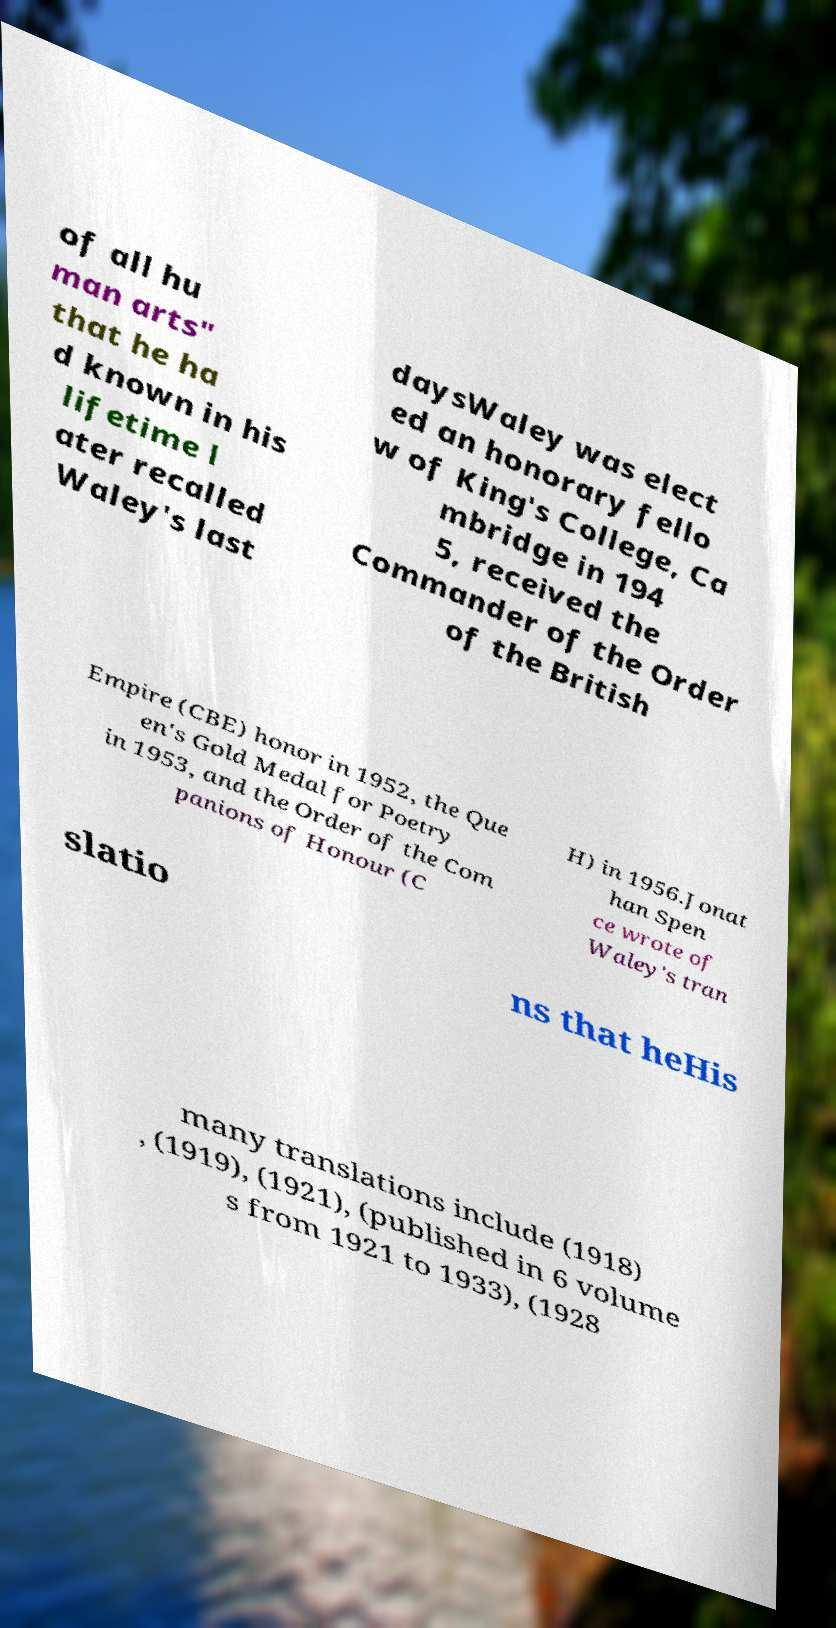There's text embedded in this image that I need extracted. Can you transcribe it verbatim? of all hu man arts" that he ha d known in his lifetime l ater recalled Waley's last daysWaley was elect ed an honorary fello w of King's College, Ca mbridge in 194 5, received the Commander of the Order of the British Empire (CBE) honor in 1952, the Que en's Gold Medal for Poetry in 1953, and the Order of the Com panions of Honour (C H) in 1956.Jonat han Spen ce wrote of Waley's tran slatio ns that heHis many translations include (1918) , (1919), (1921), (published in 6 volume s from 1921 to 1933), (1928 